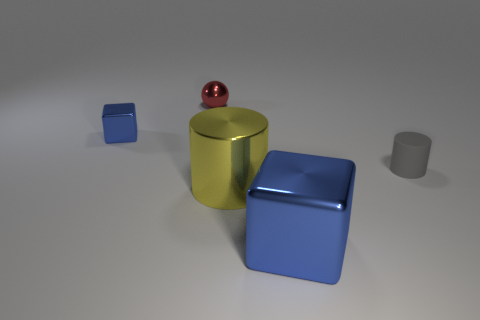Add 2 small cyan shiny objects. How many objects exist? 7 Subtract all spheres. How many objects are left? 4 Subtract all tiny gray rubber cylinders. Subtract all rubber things. How many objects are left? 3 Add 1 small blue metallic things. How many small blue metallic things are left? 2 Add 3 metallic things. How many metallic things exist? 7 Subtract 2 blue cubes. How many objects are left? 3 